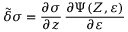<formula> <loc_0><loc_0><loc_500><loc_500>\tilde { \delta } \sigma = \frac { \partial \sigma } { \partial \boldsymbol z } \, \frac { \partial \Psi ( Z , \varepsilon ) } { \partial \varepsilon }</formula> 